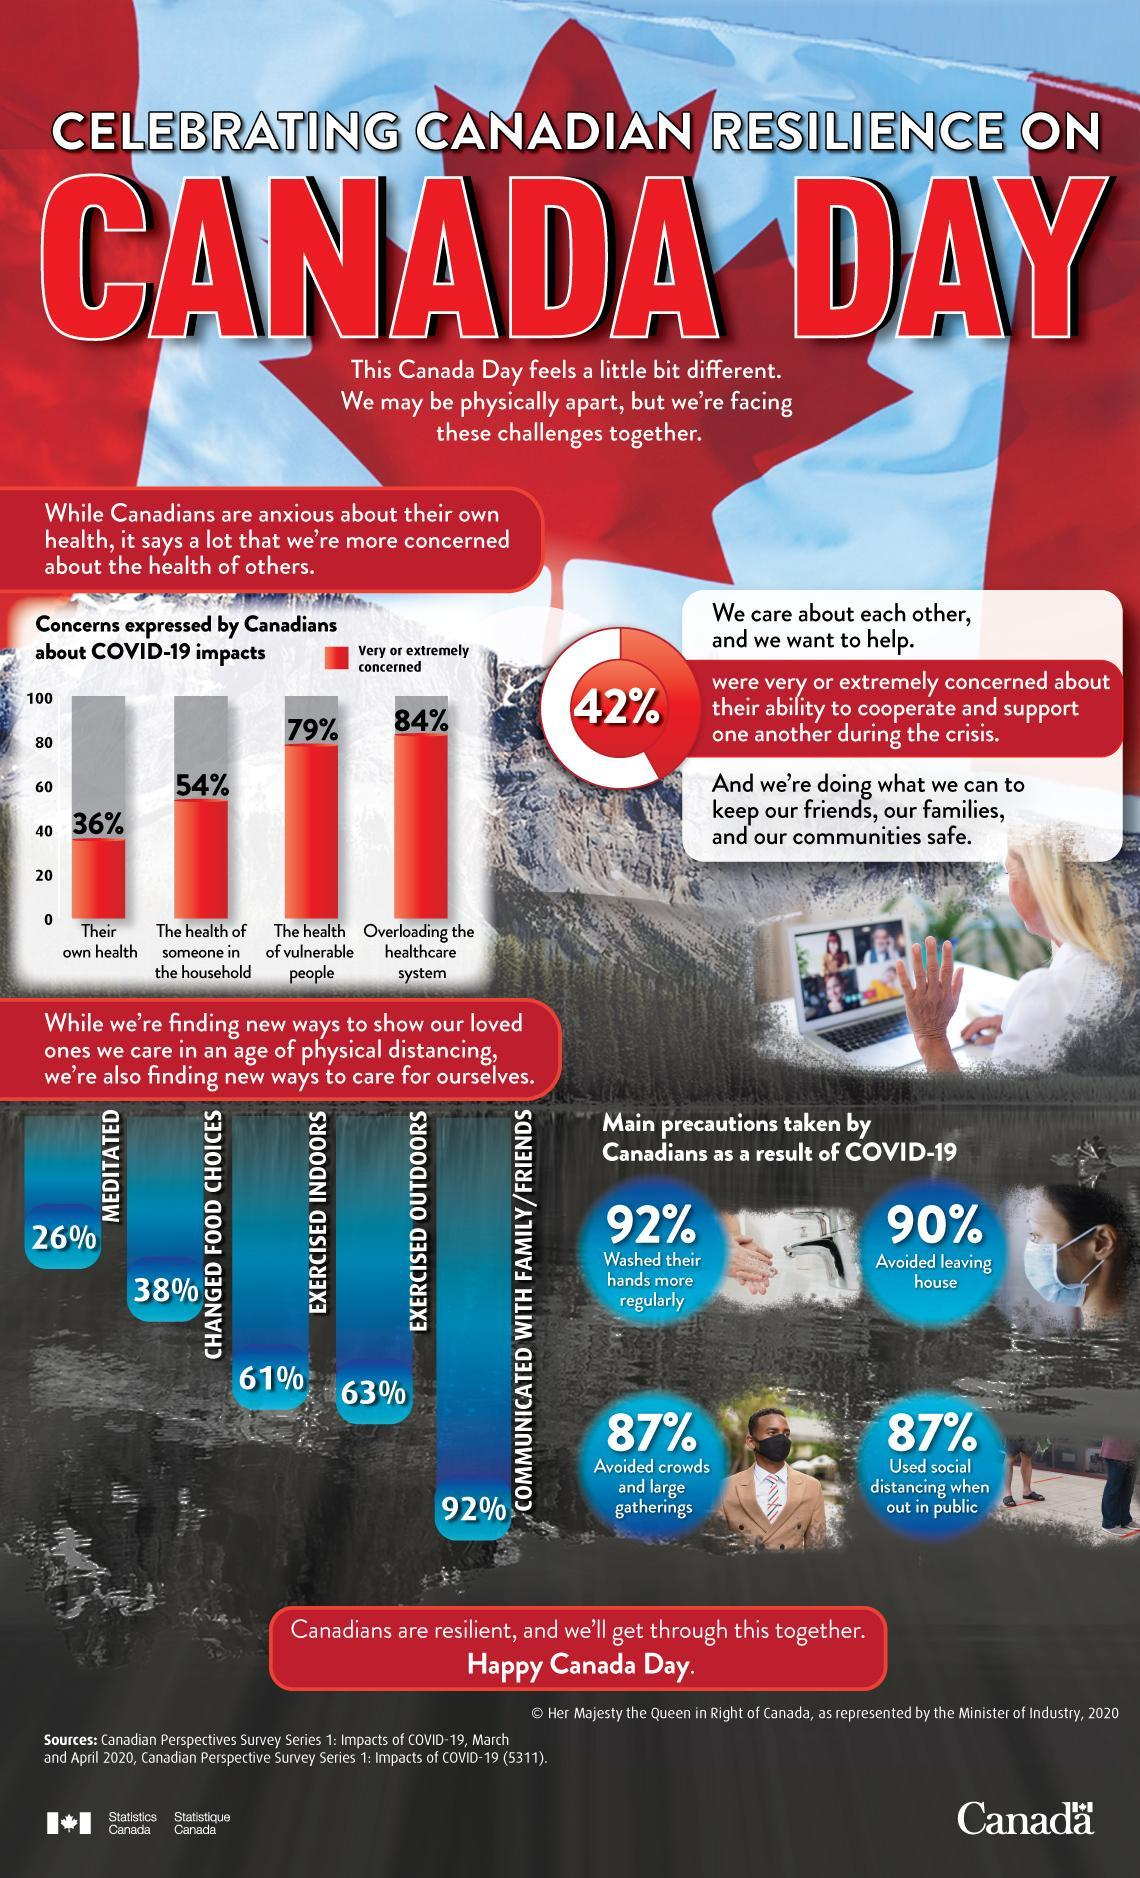What is the biggest concern of Canadians about COVID-19 impacts?
Answer the question with a short phrase. Overloading the healthcare system 